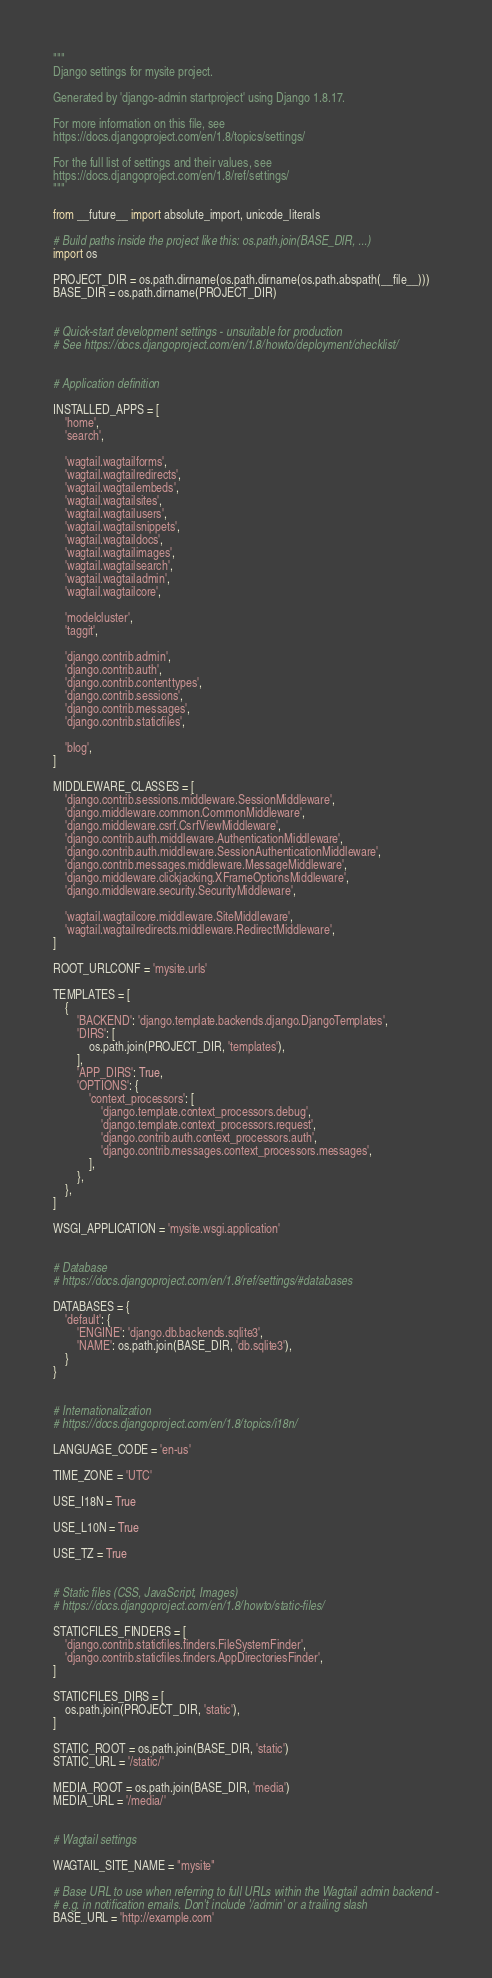Convert code to text. <code><loc_0><loc_0><loc_500><loc_500><_Python_>"""
Django settings for mysite project.

Generated by 'django-admin startproject' using Django 1.8.17.

For more information on this file, see
https://docs.djangoproject.com/en/1.8/topics/settings/

For the full list of settings and their values, see
https://docs.djangoproject.com/en/1.8/ref/settings/
"""

from __future__ import absolute_import, unicode_literals

# Build paths inside the project like this: os.path.join(BASE_DIR, ...)
import os

PROJECT_DIR = os.path.dirname(os.path.dirname(os.path.abspath(__file__)))
BASE_DIR = os.path.dirname(PROJECT_DIR)


# Quick-start development settings - unsuitable for production
# See https://docs.djangoproject.com/en/1.8/howto/deployment/checklist/


# Application definition

INSTALLED_APPS = [
    'home',
    'search',

    'wagtail.wagtailforms',
    'wagtail.wagtailredirects',
    'wagtail.wagtailembeds',
    'wagtail.wagtailsites',
    'wagtail.wagtailusers',
    'wagtail.wagtailsnippets',
    'wagtail.wagtaildocs',
    'wagtail.wagtailimages',
    'wagtail.wagtailsearch',
    'wagtail.wagtailadmin',
    'wagtail.wagtailcore',

    'modelcluster',
    'taggit',

    'django.contrib.admin',
    'django.contrib.auth',
    'django.contrib.contenttypes',
    'django.contrib.sessions',
    'django.contrib.messages',
    'django.contrib.staticfiles',

    'blog',
]

MIDDLEWARE_CLASSES = [
    'django.contrib.sessions.middleware.SessionMiddleware',
    'django.middleware.common.CommonMiddleware',
    'django.middleware.csrf.CsrfViewMiddleware',
    'django.contrib.auth.middleware.AuthenticationMiddleware',
    'django.contrib.auth.middleware.SessionAuthenticationMiddleware',
    'django.contrib.messages.middleware.MessageMiddleware',
    'django.middleware.clickjacking.XFrameOptionsMiddleware',
    'django.middleware.security.SecurityMiddleware',

    'wagtail.wagtailcore.middleware.SiteMiddleware',
    'wagtail.wagtailredirects.middleware.RedirectMiddleware',
]

ROOT_URLCONF = 'mysite.urls'

TEMPLATES = [
    {
        'BACKEND': 'django.template.backends.django.DjangoTemplates',
        'DIRS': [
            os.path.join(PROJECT_DIR, 'templates'),
        ],
        'APP_DIRS': True,
        'OPTIONS': {
            'context_processors': [
                'django.template.context_processors.debug',
                'django.template.context_processors.request',
                'django.contrib.auth.context_processors.auth',
                'django.contrib.messages.context_processors.messages',
            ],
        },
    },
]

WSGI_APPLICATION = 'mysite.wsgi.application'


# Database
# https://docs.djangoproject.com/en/1.8/ref/settings/#databases

DATABASES = {
    'default': {
        'ENGINE': 'django.db.backends.sqlite3',
        'NAME': os.path.join(BASE_DIR, 'db.sqlite3'),
    }
}


# Internationalization
# https://docs.djangoproject.com/en/1.8/topics/i18n/

LANGUAGE_CODE = 'en-us'

TIME_ZONE = 'UTC'

USE_I18N = True

USE_L10N = True

USE_TZ = True


# Static files (CSS, JavaScript, Images)
# https://docs.djangoproject.com/en/1.8/howto/static-files/

STATICFILES_FINDERS = [
    'django.contrib.staticfiles.finders.FileSystemFinder',
    'django.contrib.staticfiles.finders.AppDirectoriesFinder',
]

STATICFILES_DIRS = [
    os.path.join(PROJECT_DIR, 'static'),
]

STATIC_ROOT = os.path.join(BASE_DIR, 'static')
STATIC_URL = '/static/'

MEDIA_ROOT = os.path.join(BASE_DIR, 'media')
MEDIA_URL = '/media/'


# Wagtail settings

WAGTAIL_SITE_NAME = "mysite"

# Base URL to use when referring to full URLs within the Wagtail admin backend -
# e.g. in notification emails. Don't include '/admin' or a trailing slash
BASE_URL = 'http://example.com'
</code> 